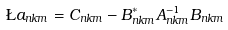Convert formula to latex. <formula><loc_0><loc_0><loc_500><loc_500>\L a _ { n k m } = C _ { n k m } - B ^ { * } _ { n k m } A ^ { - 1 } _ { n k m } B _ { n k m }</formula> 